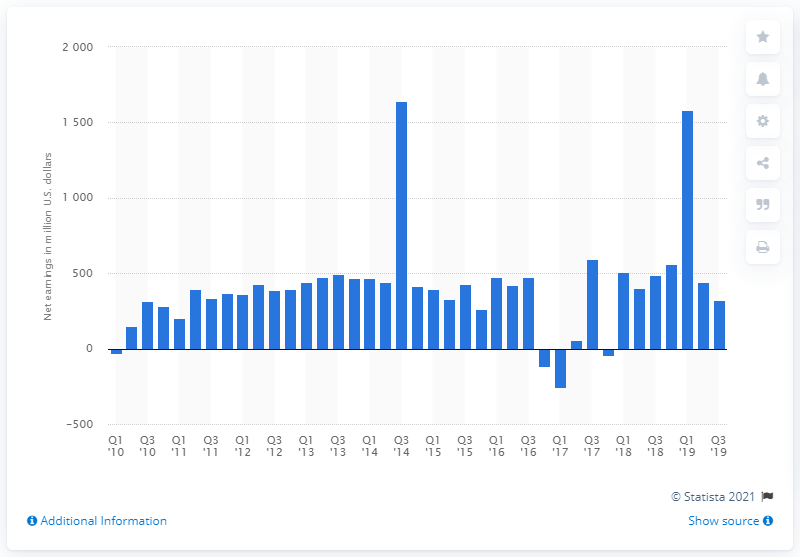Give some essential details in this illustration. The net income of CBS Corporation in the third quarter of 2019 was $319 million. In the third quarter of 2019, CBS reported revenues of 488. The net income of CBS Corporation in the corresponding quarter of the previous year was 488. 